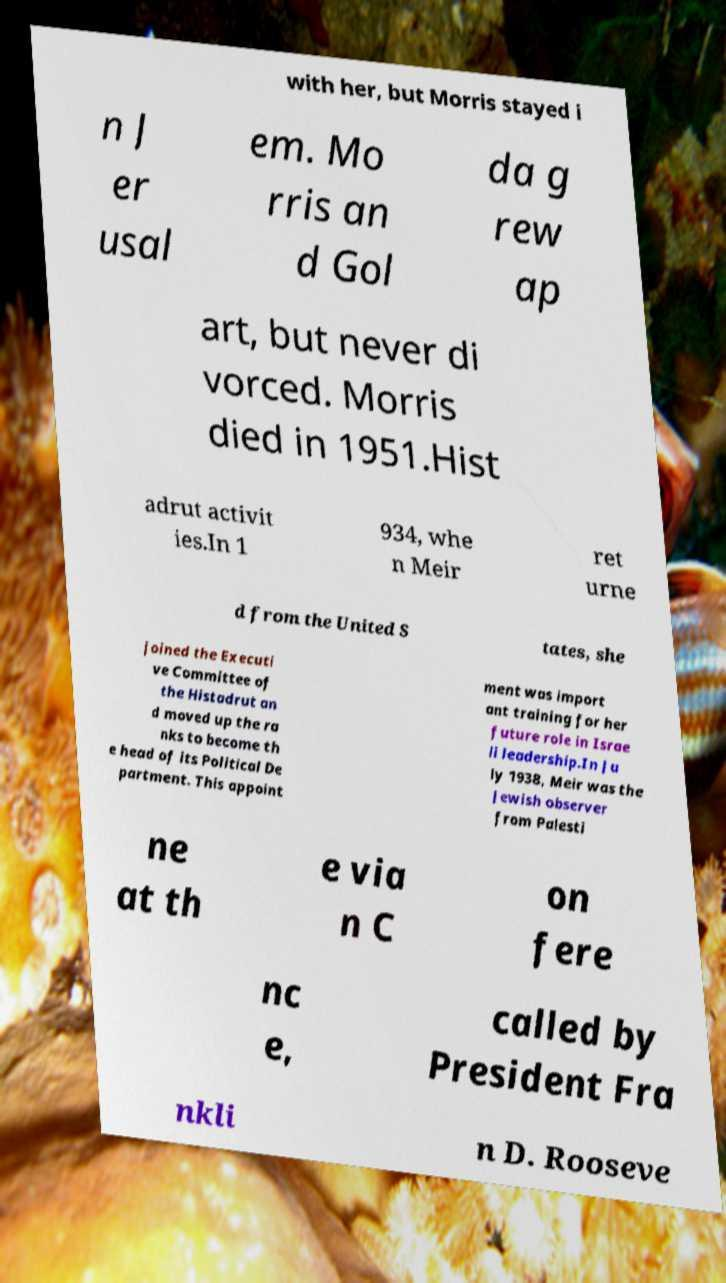For documentation purposes, I need the text within this image transcribed. Could you provide that? with her, but Morris stayed i n J er usal em. Mo rris an d Gol da g rew ap art, but never di vorced. Morris died in 1951.Hist adrut activit ies.In 1 934, whe n Meir ret urne d from the United S tates, she joined the Executi ve Committee of the Histadrut an d moved up the ra nks to become th e head of its Political De partment. This appoint ment was import ant training for her future role in Israe li leadership.In Ju ly 1938, Meir was the Jewish observer from Palesti ne at th e via n C on fere nc e, called by President Fra nkli n D. Rooseve 